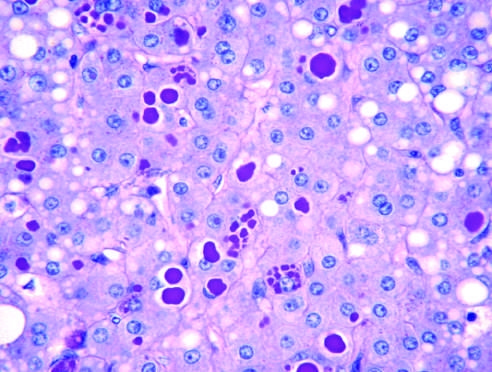does a peripheral blood smear stain after diastase digestion of the liver?
Answer the question using a single word or phrase. No 